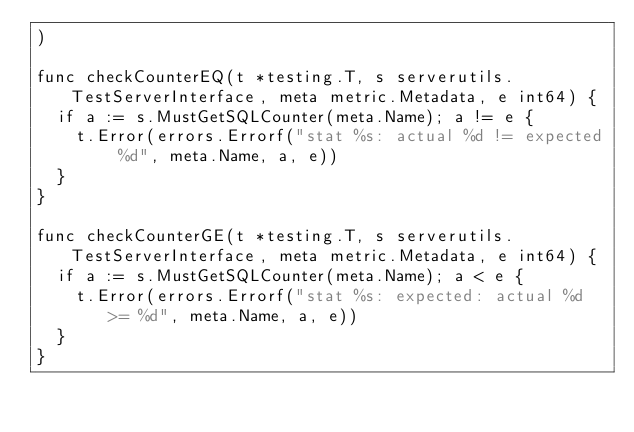Convert code to text. <code><loc_0><loc_0><loc_500><loc_500><_Go_>)

func checkCounterEQ(t *testing.T, s serverutils.TestServerInterface, meta metric.Metadata, e int64) {
	if a := s.MustGetSQLCounter(meta.Name); a != e {
		t.Error(errors.Errorf("stat %s: actual %d != expected %d", meta.Name, a, e))
	}
}

func checkCounterGE(t *testing.T, s serverutils.TestServerInterface, meta metric.Metadata, e int64) {
	if a := s.MustGetSQLCounter(meta.Name); a < e {
		t.Error(errors.Errorf("stat %s: expected: actual %d >= %d", meta.Name, a, e))
	}
}
</code> 